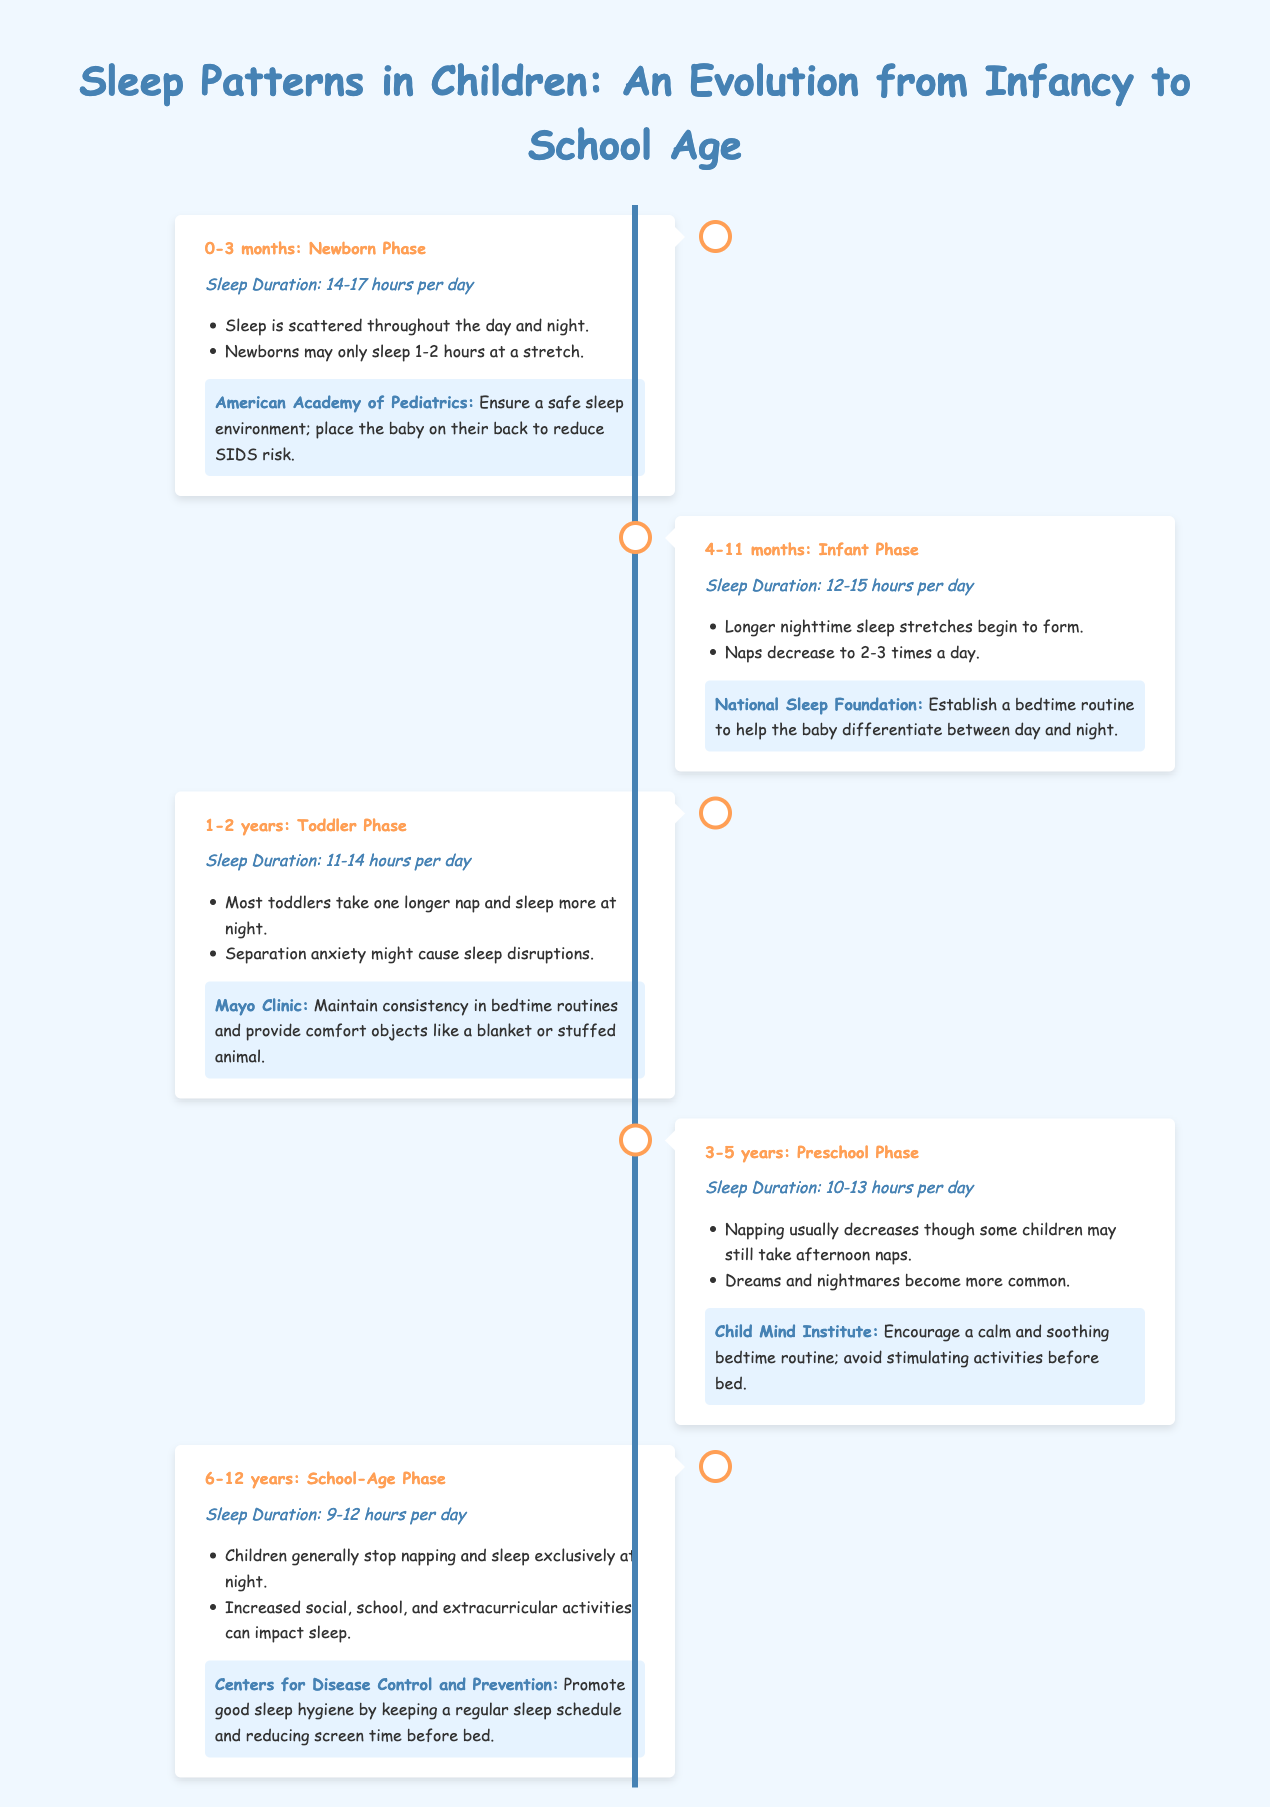What is the sleep duration for newborns? The sleep duration for newborns is mentioned at the beginning of the timeline for the 0-3 months phase, which states 14-17 hours per day.
Answer: 14-17 hours per day What age range corresponds to the Toddler Phase? The Toddler Phase is highlighted in the timeline, specifically for the age range of 1-2 years.
Answer: 1-2 years How many naps do infants typically take? The information for the Infant Phase indicates that naps decrease to 2-3 times a day.
Answer: 2-3 times Which recommendation comes from the American Academy of Pediatrics? The recommendation provided by the American Academy of Pediatrics focuses on ensuring a safe sleep environment by placing the baby on their back to reduce SIDS risk.
Answer: Ensure a safe sleep environment; place the baby on their back to reduce SIDS risk At what age do most children stop napping? The School-Age Phase mentions that children generally stop napping, which applies to the age range of 6-12 years.
Answer: 6-12 years What influence can increased activities have on sleep? The School-Age Phase notes that increased social, school, and extracurricular activities can impact sleep, suggesting a direct correlation.
Answer: Impact sleep What is a common sleep duration for preschoolers? The sleep duration specified for preschoolers in the 3-5 years phase is 10-13 hours per day.
Answer: 10-13 hours per day What aspect is emphasized for toddlers to aid their sleep? The recommendation from the Mayo Clinic emphasizes maintaining consistency in bedtime routines.
Answer: Consistency in bedtime routines What is an important practice to promote good sleep hygiene according to the CDC? The Centers for Disease Control and Prevention's recommendation highlights keeping a regular sleep schedule as an important practice.
Answer: Regular sleep schedule 